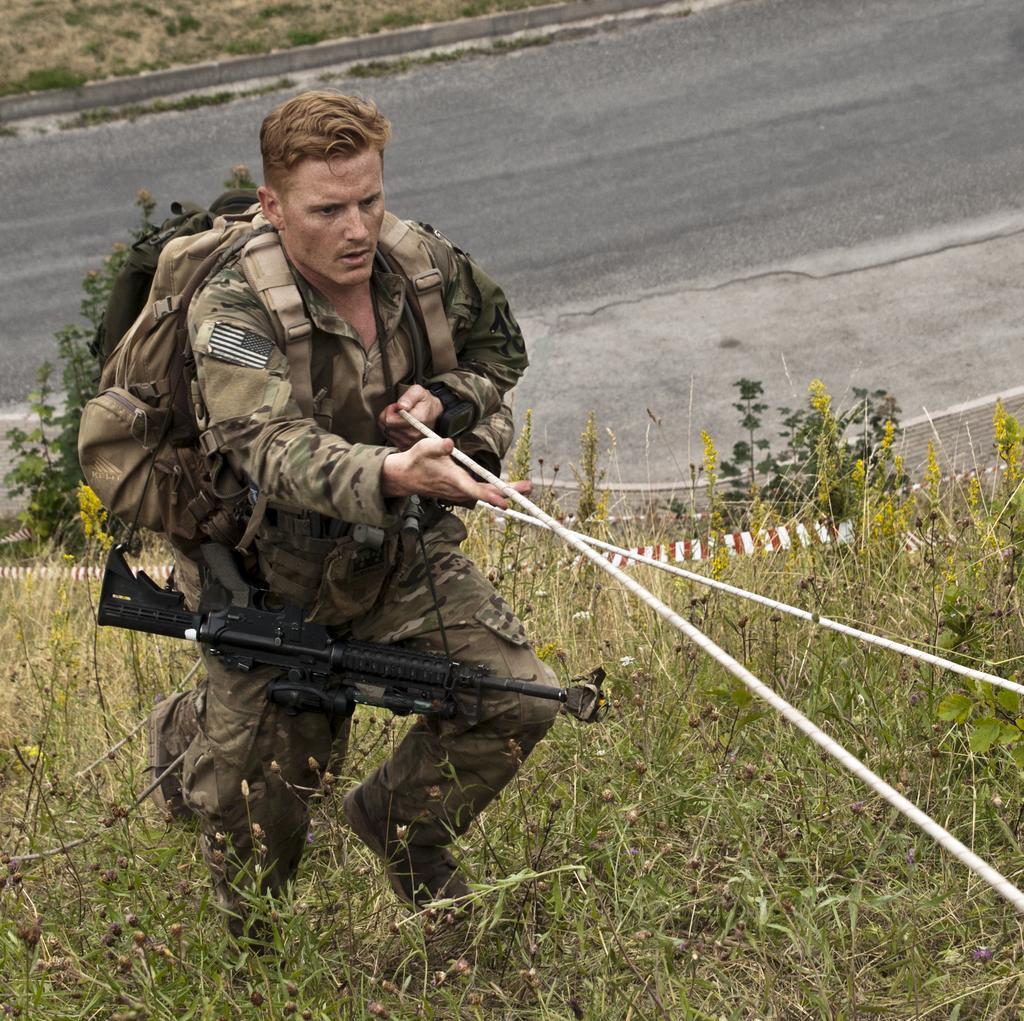Could you give a brief overview of what you see in this image? In this image, we can see a person holding some object. We can see the ground. We can see some grass, plants. 